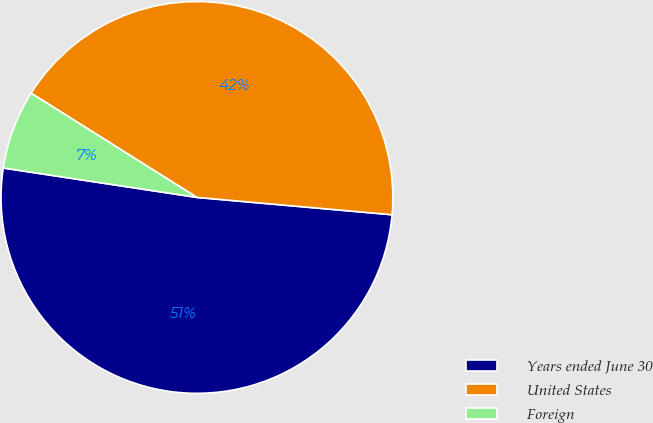Convert chart. <chart><loc_0><loc_0><loc_500><loc_500><pie_chart><fcel>Years ended June 30<fcel>United States<fcel>Foreign<nl><fcel>50.99%<fcel>42.48%<fcel>6.53%<nl></chart> 